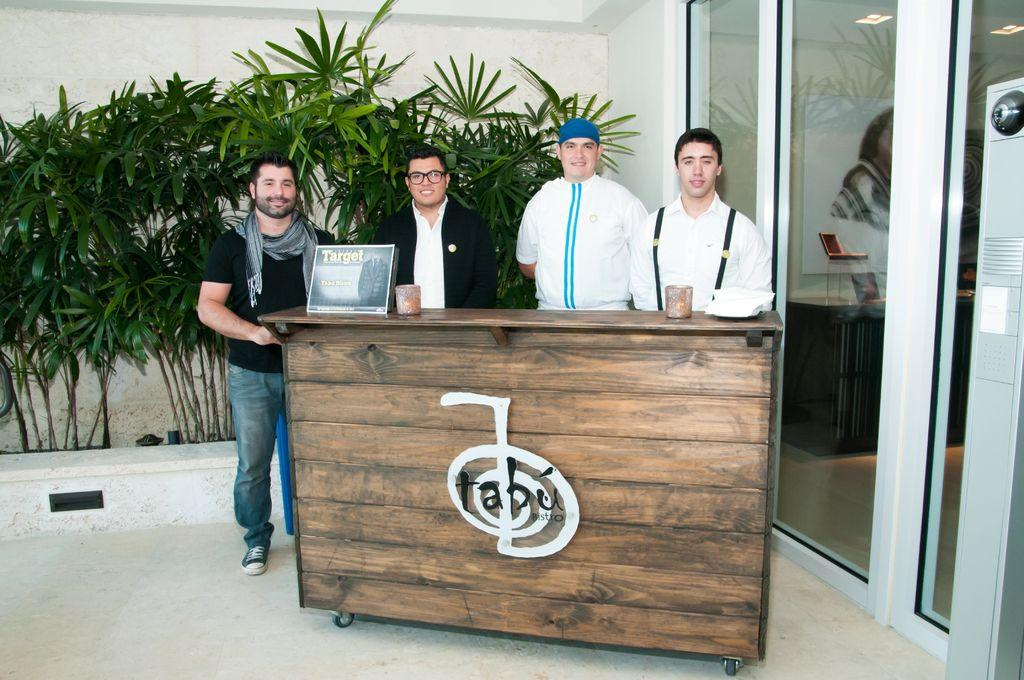How many people are in the image? There are four persons in the image. Where are the four persons located in the image? The four persons are standing near the front desk. What are the four persons doing in the image? The four persons are giving a pose for the picture. What can be seen in the background of the image? There are plants and a glass door in the background of the image. What type of basket is being used for educational purposes in the image? There is no basket or educational activity present in the image. How does the pest affect the plants in the background of the image? There is no pest or indication of plant damage in the image. 